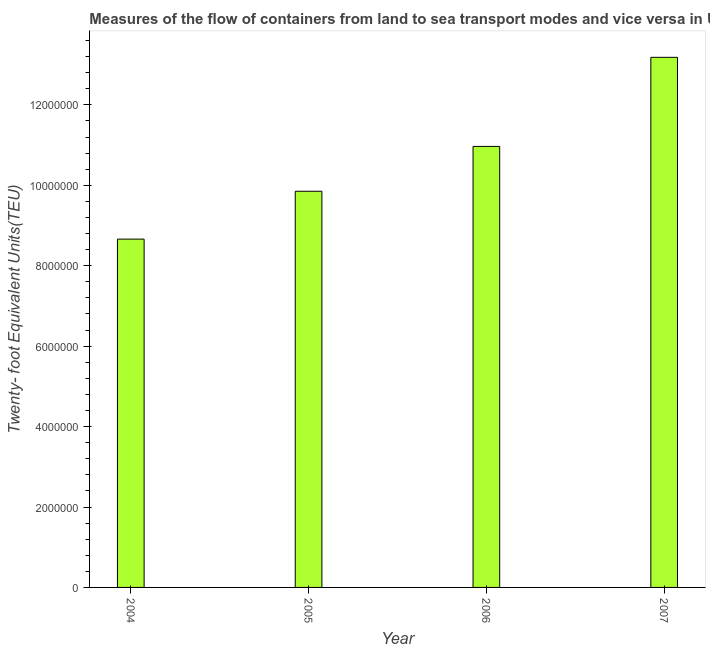Does the graph contain grids?
Ensure brevity in your answer.  No. What is the title of the graph?
Offer a terse response. Measures of the flow of containers from land to sea transport modes and vice versa in United Arab Emirates. What is the label or title of the X-axis?
Keep it short and to the point. Year. What is the label or title of the Y-axis?
Offer a very short reply. Twenty- foot Equivalent Units(TEU). What is the container port traffic in 2007?
Give a very brief answer. 1.32e+07. Across all years, what is the maximum container port traffic?
Your response must be concise. 1.32e+07. Across all years, what is the minimum container port traffic?
Your answer should be very brief. 8.66e+06. In which year was the container port traffic maximum?
Ensure brevity in your answer.  2007. What is the sum of the container port traffic?
Provide a short and direct response. 4.27e+07. What is the difference between the container port traffic in 2005 and 2007?
Ensure brevity in your answer.  -3.33e+06. What is the average container port traffic per year?
Your response must be concise. 1.07e+07. What is the median container port traffic?
Ensure brevity in your answer.  1.04e+07. In how many years, is the container port traffic greater than 12000000 TEU?
Provide a succinct answer. 1. Do a majority of the years between 2006 and 2005 (inclusive) have container port traffic greater than 10800000 TEU?
Your response must be concise. No. What is the ratio of the container port traffic in 2005 to that in 2007?
Provide a succinct answer. 0.75. Is the container port traffic in 2005 less than that in 2006?
Offer a very short reply. Yes. Is the difference between the container port traffic in 2005 and 2006 greater than the difference between any two years?
Offer a terse response. No. What is the difference between the highest and the second highest container port traffic?
Your response must be concise. 2.22e+06. What is the difference between the highest and the lowest container port traffic?
Your answer should be compact. 4.52e+06. How many bars are there?
Your answer should be very brief. 4. Are all the bars in the graph horizontal?
Keep it short and to the point. No. What is the difference between two consecutive major ticks on the Y-axis?
Your answer should be very brief. 2.00e+06. What is the Twenty- foot Equivalent Units(TEU) in 2004?
Provide a succinct answer. 8.66e+06. What is the Twenty- foot Equivalent Units(TEU) in 2005?
Ensure brevity in your answer.  9.85e+06. What is the Twenty- foot Equivalent Units(TEU) of 2006?
Give a very brief answer. 1.10e+07. What is the Twenty- foot Equivalent Units(TEU) in 2007?
Your response must be concise. 1.32e+07. What is the difference between the Twenty- foot Equivalent Units(TEU) in 2004 and 2005?
Ensure brevity in your answer.  -1.19e+06. What is the difference between the Twenty- foot Equivalent Units(TEU) in 2004 and 2006?
Keep it short and to the point. -2.31e+06. What is the difference between the Twenty- foot Equivalent Units(TEU) in 2004 and 2007?
Provide a succinct answer. -4.52e+06. What is the difference between the Twenty- foot Equivalent Units(TEU) in 2005 and 2006?
Provide a short and direct response. -1.12e+06. What is the difference between the Twenty- foot Equivalent Units(TEU) in 2005 and 2007?
Your response must be concise. -3.33e+06. What is the difference between the Twenty- foot Equivalent Units(TEU) in 2006 and 2007?
Provide a short and direct response. -2.22e+06. What is the ratio of the Twenty- foot Equivalent Units(TEU) in 2004 to that in 2005?
Make the answer very short. 0.88. What is the ratio of the Twenty- foot Equivalent Units(TEU) in 2004 to that in 2006?
Your answer should be very brief. 0.79. What is the ratio of the Twenty- foot Equivalent Units(TEU) in 2004 to that in 2007?
Keep it short and to the point. 0.66. What is the ratio of the Twenty- foot Equivalent Units(TEU) in 2005 to that in 2006?
Make the answer very short. 0.9. What is the ratio of the Twenty- foot Equivalent Units(TEU) in 2005 to that in 2007?
Provide a short and direct response. 0.75. What is the ratio of the Twenty- foot Equivalent Units(TEU) in 2006 to that in 2007?
Keep it short and to the point. 0.83. 